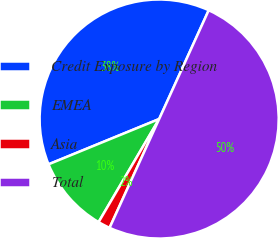<chart> <loc_0><loc_0><loc_500><loc_500><pie_chart><fcel>Credit Exposure by Region<fcel>EMEA<fcel>Asia<fcel>Total<nl><fcel>37.99%<fcel>10.36%<fcel>1.65%<fcel>50.0%<nl></chart> 